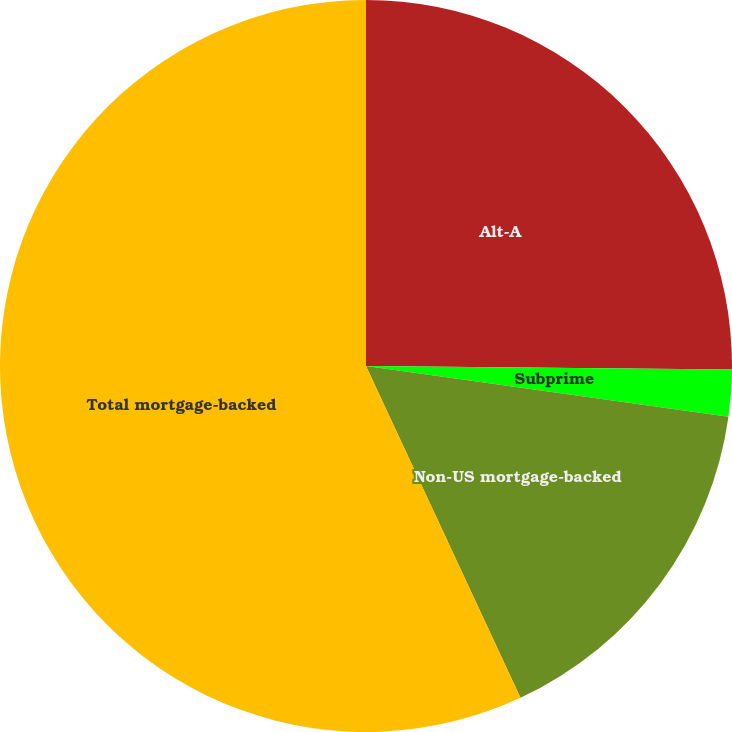Convert chart to OTSL. <chart><loc_0><loc_0><loc_500><loc_500><pie_chart><fcel>Alt-A<fcel>Subprime<fcel>Non-US mortgage-backed<fcel>Total mortgage-backed<nl><fcel>25.15%<fcel>2.07%<fcel>15.85%<fcel>56.94%<nl></chart> 